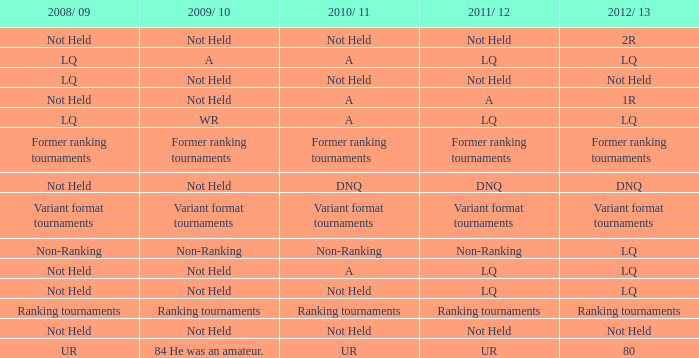When 2011/ 12 is non-ranking, what is the 2009/ 10? Non-Ranking. 